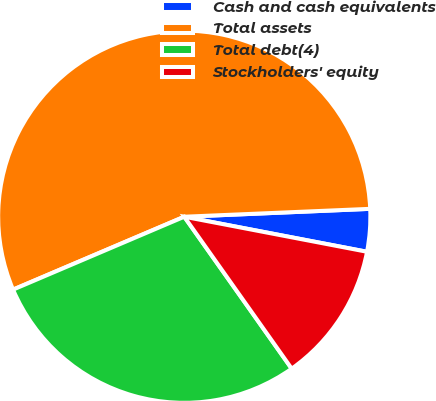<chart> <loc_0><loc_0><loc_500><loc_500><pie_chart><fcel>Cash and cash equivalents<fcel>Total assets<fcel>Total debt(4)<fcel>Stockholders' equity<nl><fcel>3.69%<fcel>55.73%<fcel>28.39%<fcel>12.19%<nl></chart> 